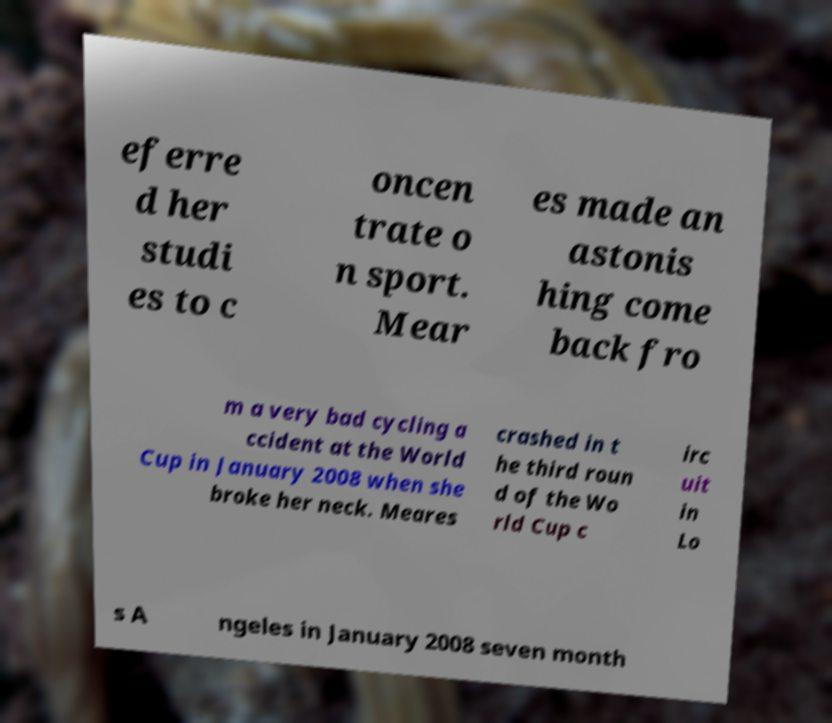I need the written content from this picture converted into text. Can you do that? eferre d her studi es to c oncen trate o n sport. Mear es made an astonis hing come back fro m a very bad cycling a ccident at the World Cup in January 2008 when she broke her neck. Meares crashed in t he third roun d of the Wo rld Cup c irc uit in Lo s A ngeles in January 2008 seven month 